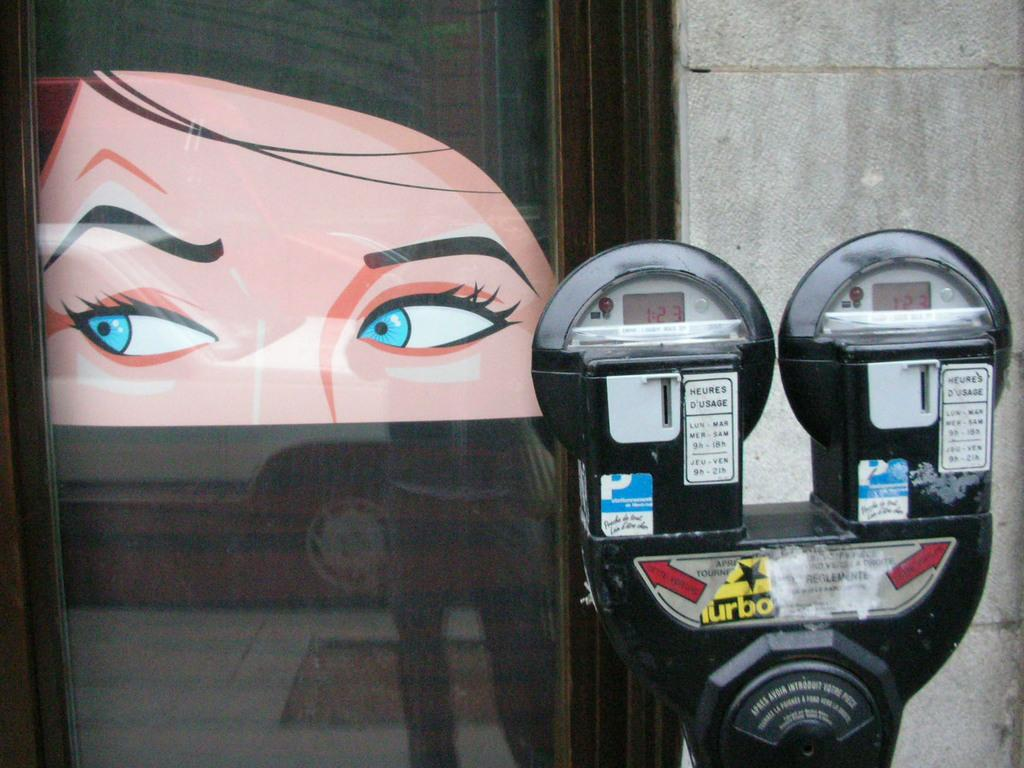<image>
Give a short and clear explanation of the subsequent image. a meter that has the word turbo on the front of it 